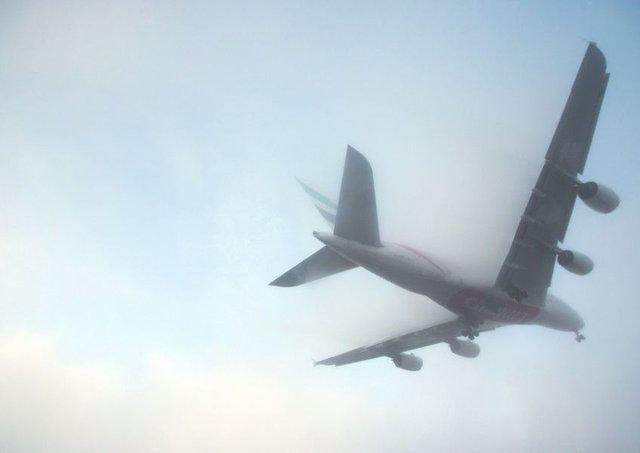Could you describe the position of the aeroplane in relation to the viewer? The aeroplane is seen from below, with the underbelly and landing gears visible. It is on a descent or located significantly above, preparing perhaps for landing or simply passing by at a lower altitude than usual during flight. 